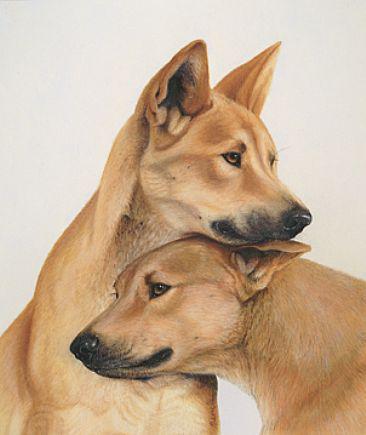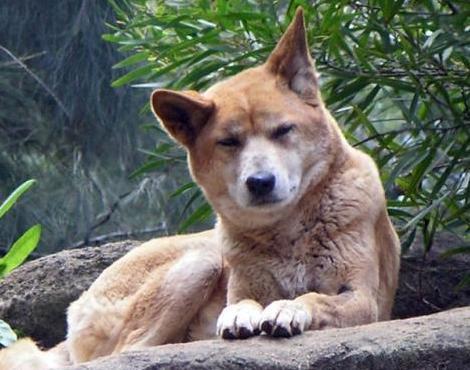The first image is the image on the left, the second image is the image on the right. Analyze the images presented: Is the assertion "There are exactly six dogs in total." valid? Answer yes or no. No. The first image is the image on the left, the second image is the image on the right. For the images displayed, is the sentence "The left image contains two dingos, with one dog's head turned left and lower than the other right-turned head, and the right image contains no dogs that are not reclining." factually correct? Answer yes or no. Yes. 